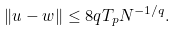Convert formula to latex. <formula><loc_0><loc_0><loc_500><loc_500>\| u - w \| \leq 8 q T _ { p } N ^ { - 1 / q } .</formula> 